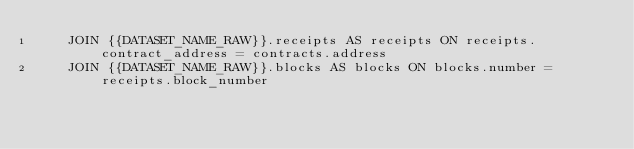<code> <loc_0><loc_0><loc_500><loc_500><_SQL_>    JOIN {{DATASET_NAME_RAW}}.receipts AS receipts ON receipts.contract_address = contracts.address
    JOIN {{DATASET_NAME_RAW}}.blocks AS blocks ON blocks.number = receipts.block_number
</code> 